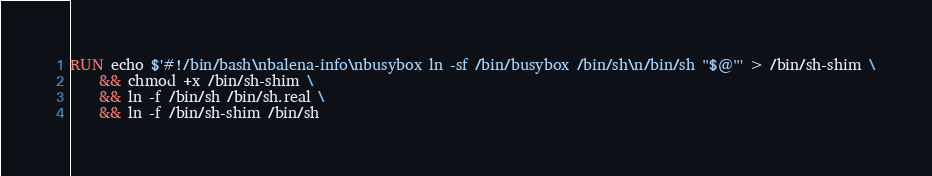<code> <loc_0><loc_0><loc_500><loc_500><_Dockerfile_>
RUN echo $'#!/bin/bash\nbalena-info\nbusybox ln -sf /bin/busybox /bin/sh\n/bin/sh "$@"' > /bin/sh-shim \
	&& chmod +x /bin/sh-shim \
	&& ln -f /bin/sh /bin/sh.real \
	&& ln -f /bin/sh-shim /bin/sh</code> 